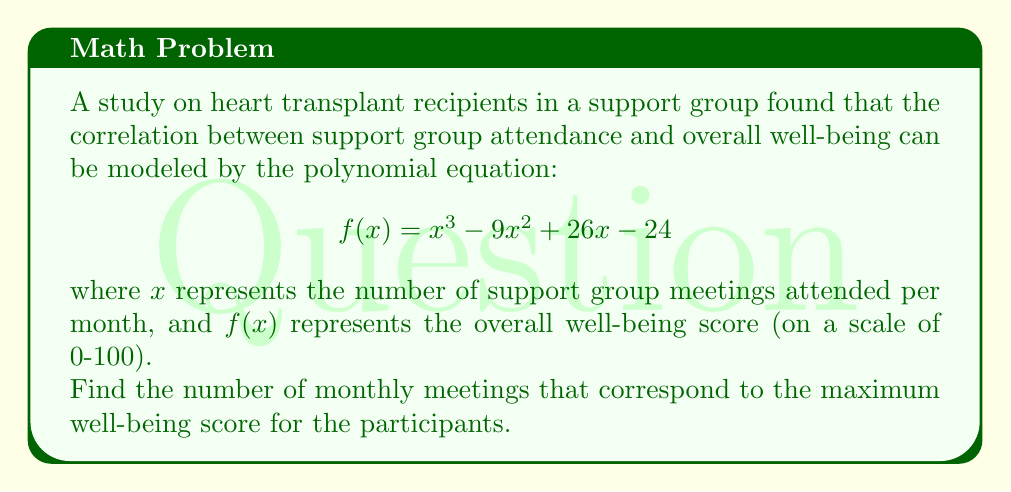Can you solve this math problem? To find the number of monthly meetings that correspond to the maximum well-being score, we need to find the local maximum of the function $f(x)$. This can be done by following these steps:

1) First, we need to find the derivative of $f(x)$:
   $$f'(x) = 3x^2 - 18x + 26$$

2) The local maximum will occur where $f'(x) = 0$. So, we need to solve the equation:
   $$3x^2 - 18x + 26 = 0$$

3) This is a quadratic equation. We can solve it using the quadratic formula:
   $$x = \frac{-b \pm \sqrt{b^2 - 4ac}}{2a}$$
   where $a = 3$, $b = -18$, and $c = 26$

4) Substituting these values:
   $$x = \frac{18 \pm \sqrt{(-18)^2 - 4(3)(26)}}{2(3)}$$
   $$= \frac{18 \pm \sqrt{324 - 312}}{6}$$
   $$= \frac{18 \pm \sqrt{12}}{6}$$
   $$= \frac{18 \pm 2\sqrt{3}}{6}$$

5) This gives us two solutions:
   $$x_1 = \frac{18 + 2\sqrt{3}}{6} = 3 + \frac{\sqrt{3}}{3}$$
   $$x_2 = \frac{18 - 2\sqrt{3}}{6} = 3 - \frac{\sqrt{3}}{3}$$

6) To determine which of these gives the maximum (rather than minimum) value, we can check the second derivative:
   $$f''(x) = 6x - 18$$

   At $x = 3 + \frac{\sqrt{3}}{3}$, $f''(x) > 0$, indicating a local minimum.
   At $x = 3 - \frac{\sqrt{3}}{3}$, $f''(x) < 0$, indicating a local maximum.

Therefore, the maximum well-being score occurs when participants attend $3 - \frac{\sqrt{3}}{3}$ meetings per month.
Answer: $3 - \frac{\sqrt{3}}{3}$ meetings per month (approximately 2.42 meetings) 